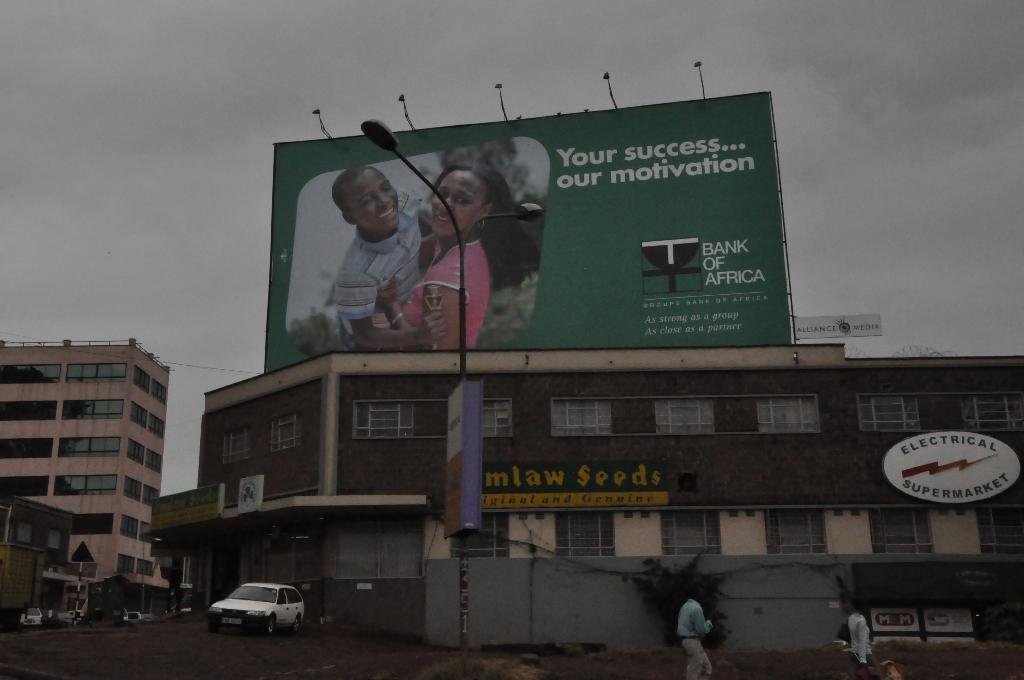<image>
Render a clear and concise summary of the photo. A large billboard above apartments about the Bank of Africa. 